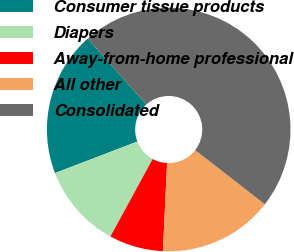Convert chart. <chart><loc_0><loc_0><loc_500><loc_500><pie_chart><fcel>Consumer tissue products<fcel>Diapers<fcel>Away-from-home professional<fcel>All other<fcel>Consolidated<nl><fcel>19.23%<fcel>11.24%<fcel>7.18%<fcel>15.24%<fcel>47.12%<nl></chart> 